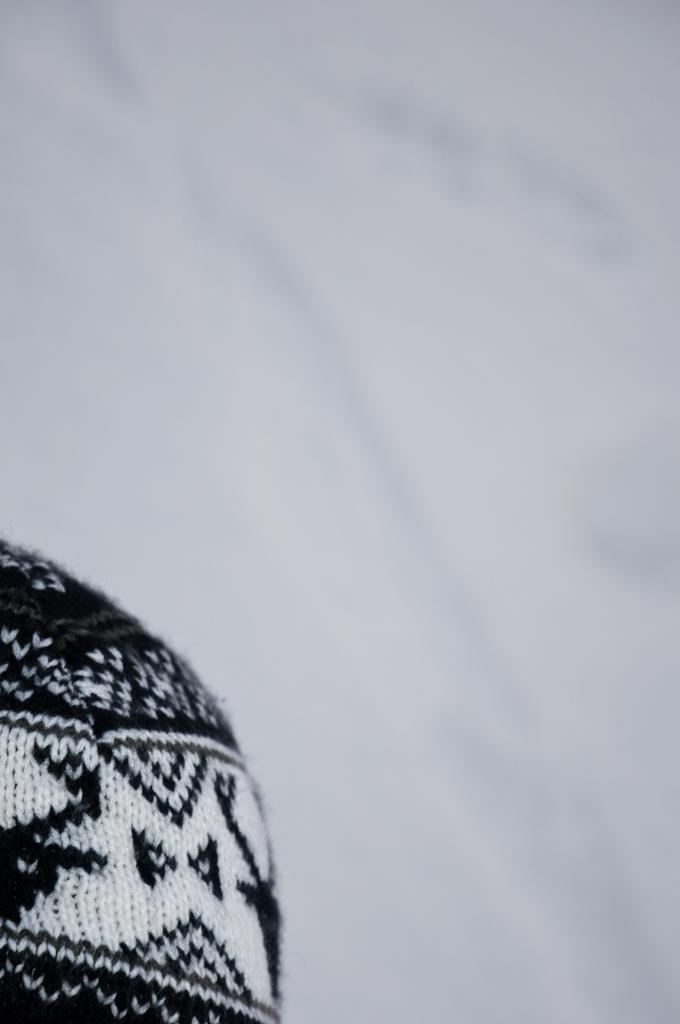What object is located on the left side bottom of the image? There is a woolen cloth on the left side bottom of the image. Can you describe the background of the image? The background of the image has a blurred view. What color can be seen in the image? There is a white color visible in the image. Are there any crayons visible on the woolen cloth in the image? There are no crayons visible on the woolen cloth in the image. Can you tell me the price of the item shown in the receipt in the image? There is no receipt present in the image. 